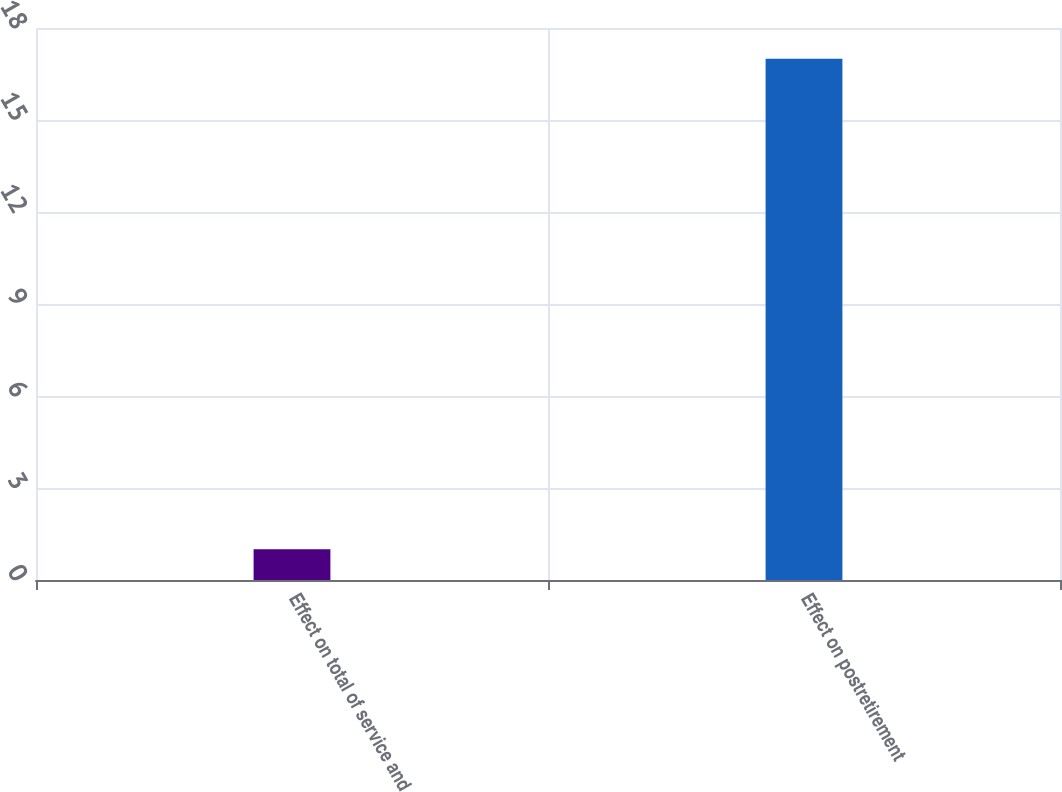Convert chart to OTSL. <chart><loc_0><loc_0><loc_500><loc_500><bar_chart><fcel>Effect on total of service and<fcel>Effect on postretirement<nl><fcel>1<fcel>17<nl></chart> 